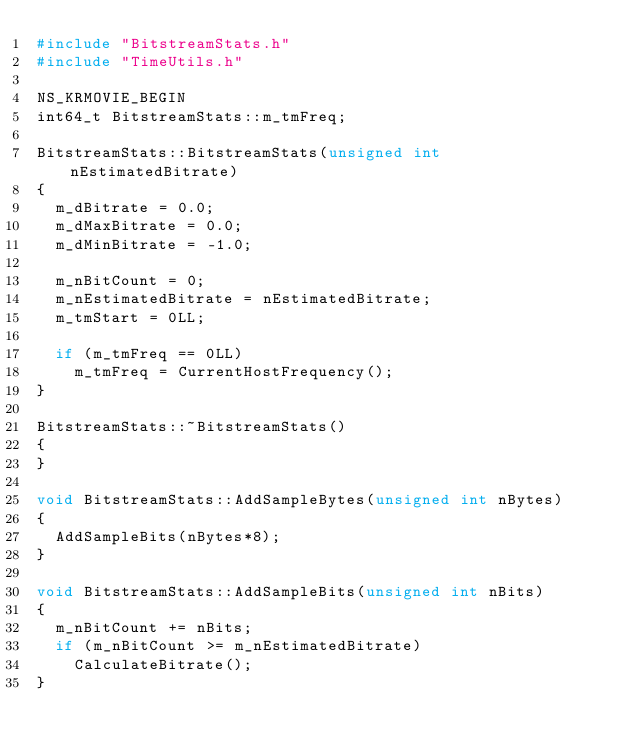Convert code to text. <code><loc_0><loc_0><loc_500><loc_500><_C++_>#include "BitstreamStats.h"
#include "TimeUtils.h"

NS_KRMOVIE_BEGIN
int64_t BitstreamStats::m_tmFreq;

BitstreamStats::BitstreamStats(unsigned int nEstimatedBitrate)
{
  m_dBitrate = 0.0;
  m_dMaxBitrate = 0.0;
  m_dMinBitrate = -1.0;

  m_nBitCount = 0;
  m_nEstimatedBitrate = nEstimatedBitrate;
  m_tmStart = 0LL;

  if (m_tmFreq == 0LL)
    m_tmFreq = CurrentHostFrequency();
}

BitstreamStats::~BitstreamStats()
{
}

void BitstreamStats::AddSampleBytes(unsigned int nBytes)
{
  AddSampleBits(nBytes*8);
}

void BitstreamStats::AddSampleBits(unsigned int nBits)
{
  m_nBitCount += nBits;
  if (m_nBitCount >= m_nEstimatedBitrate)
    CalculateBitrate();
}
</code> 